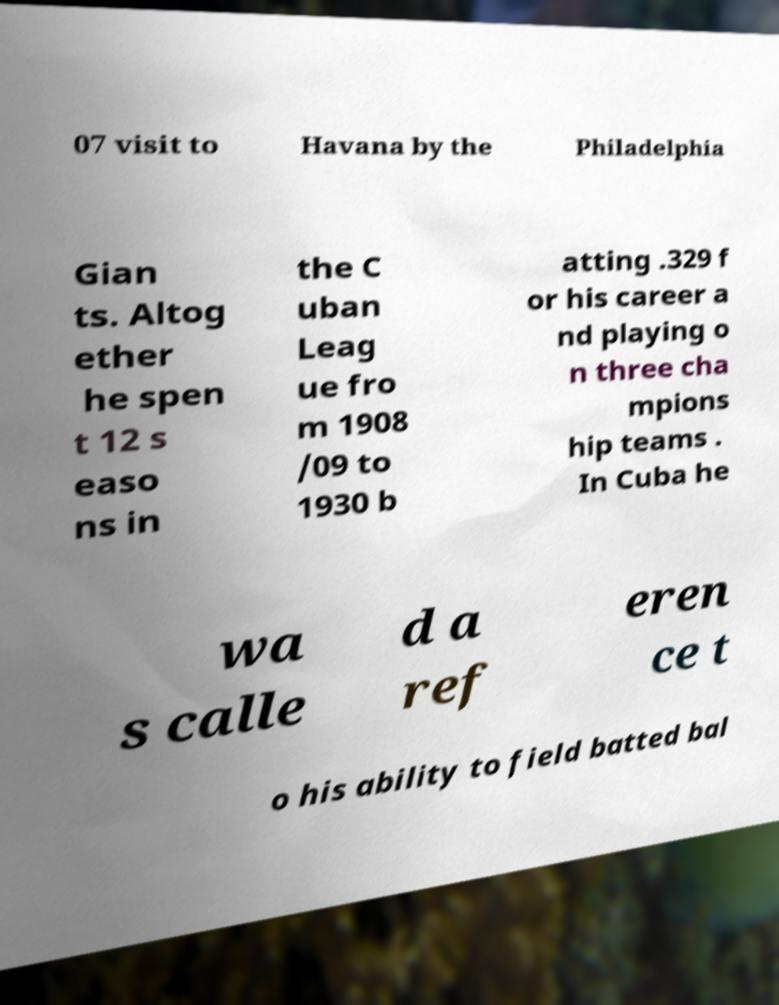There's text embedded in this image that I need extracted. Can you transcribe it verbatim? 07 visit to Havana by the Philadelphia Gian ts. Altog ether he spen t 12 s easo ns in the C uban Leag ue fro m 1908 /09 to 1930 b atting .329 f or his career a nd playing o n three cha mpions hip teams . In Cuba he wa s calle d a ref eren ce t o his ability to field batted bal 